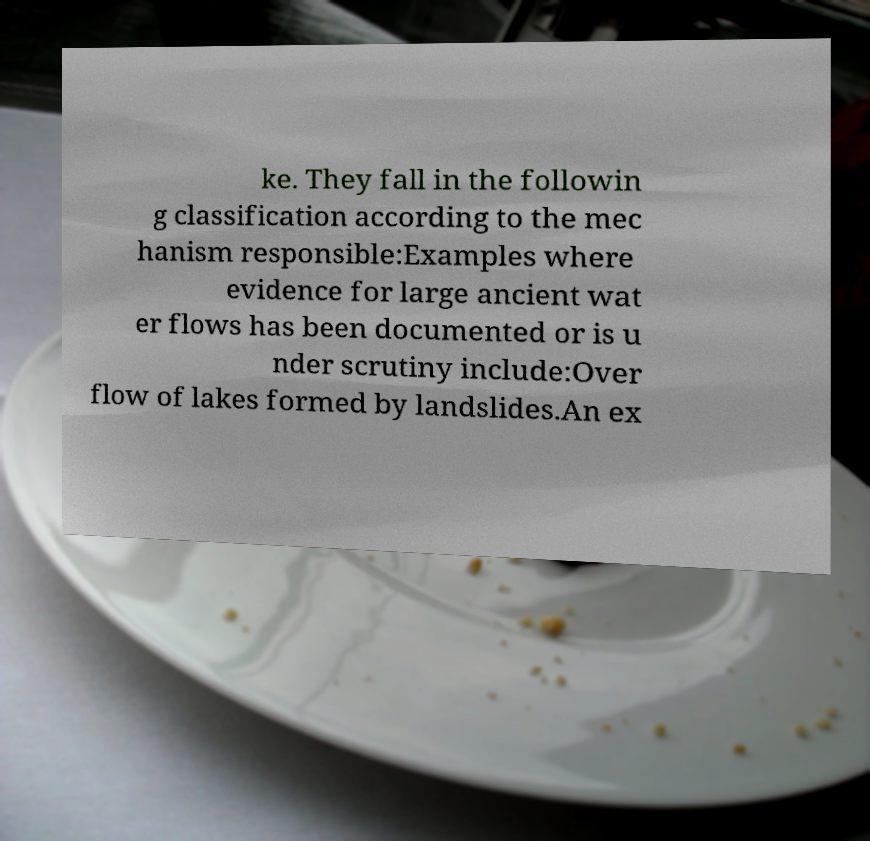Please read and relay the text visible in this image. What does it say? ke. They fall in the followin g classification according to the mec hanism responsible:Examples where evidence for large ancient wat er flows has been documented or is u nder scrutiny include:Over flow of lakes formed by landslides.An ex 